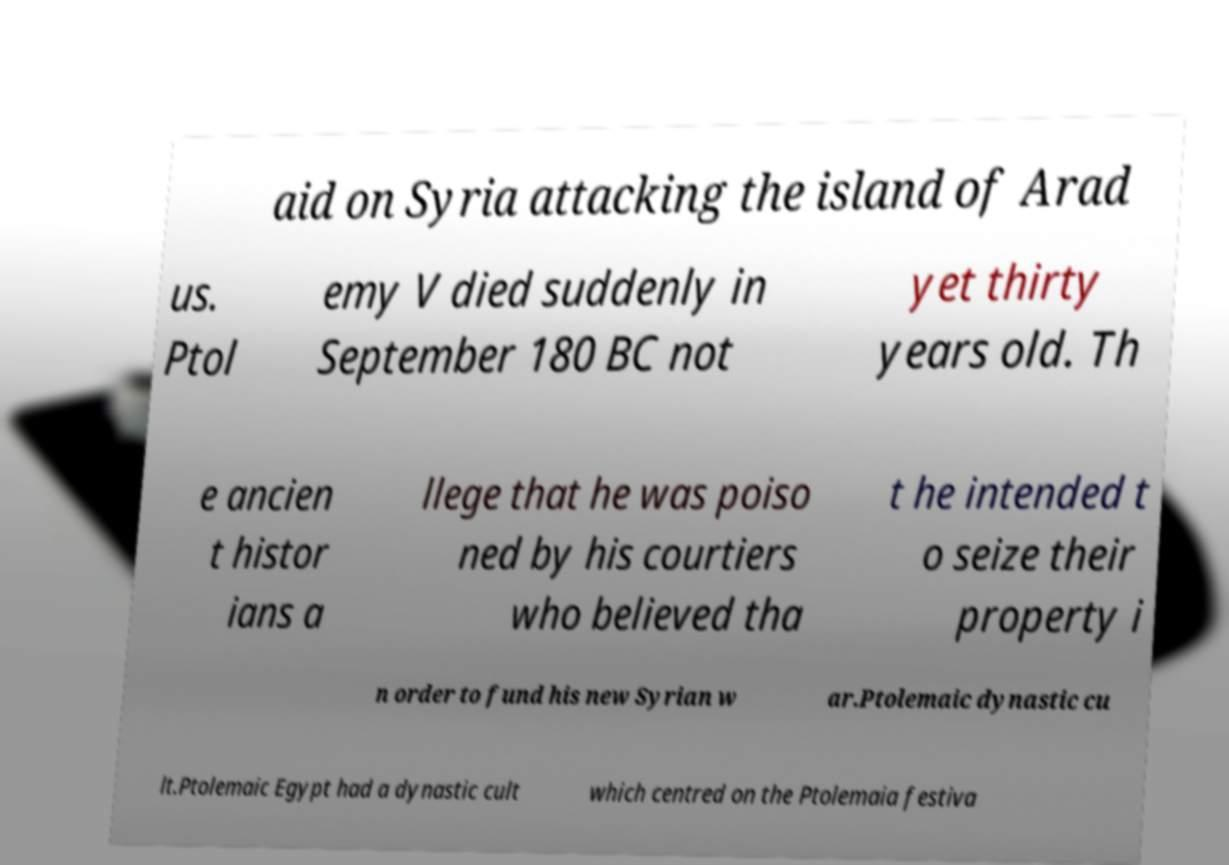There's text embedded in this image that I need extracted. Can you transcribe it verbatim? aid on Syria attacking the island of Arad us. Ptol emy V died suddenly in September 180 BC not yet thirty years old. Th e ancien t histor ians a llege that he was poiso ned by his courtiers who believed tha t he intended t o seize their property i n order to fund his new Syrian w ar.Ptolemaic dynastic cu lt.Ptolemaic Egypt had a dynastic cult which centred on the Ptolemaia festiva 